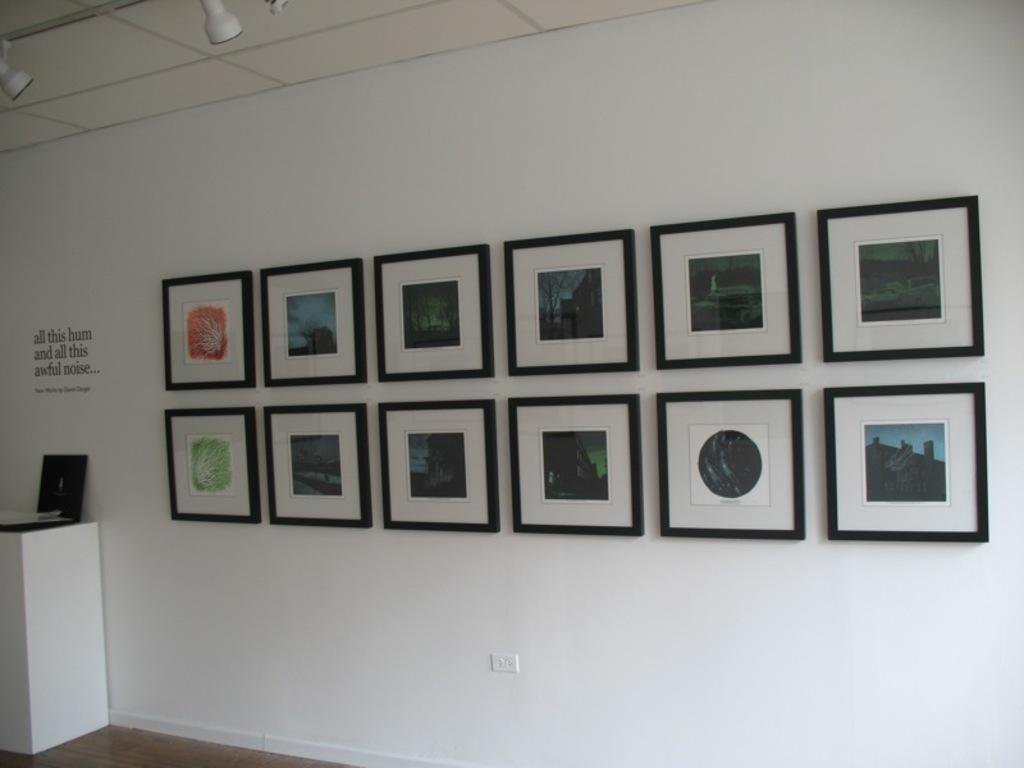What is hanging on the white wall in the image? There are photo frames on a white wall in the image. How are the photo frames arranged on the wall? The photo frames are arranged in 2 rows on the wall. What electronic device can be seen on the left side of the image? There is a laptop on the left side of the image. What is written on the left side of the wall? There is writing on the left side of the wall. What type of lighting is visible in the image? There are lights on the top of the image. How many snakes are slithering on the laptop in the image? There are no snakes present in the image, and the laptop is not depicted as having any snakes on it. What type of detail can be seen on the photo frames in the image? The provided facts do not mention any specific details on the photo frames, so we cannot answer this question definitively. 